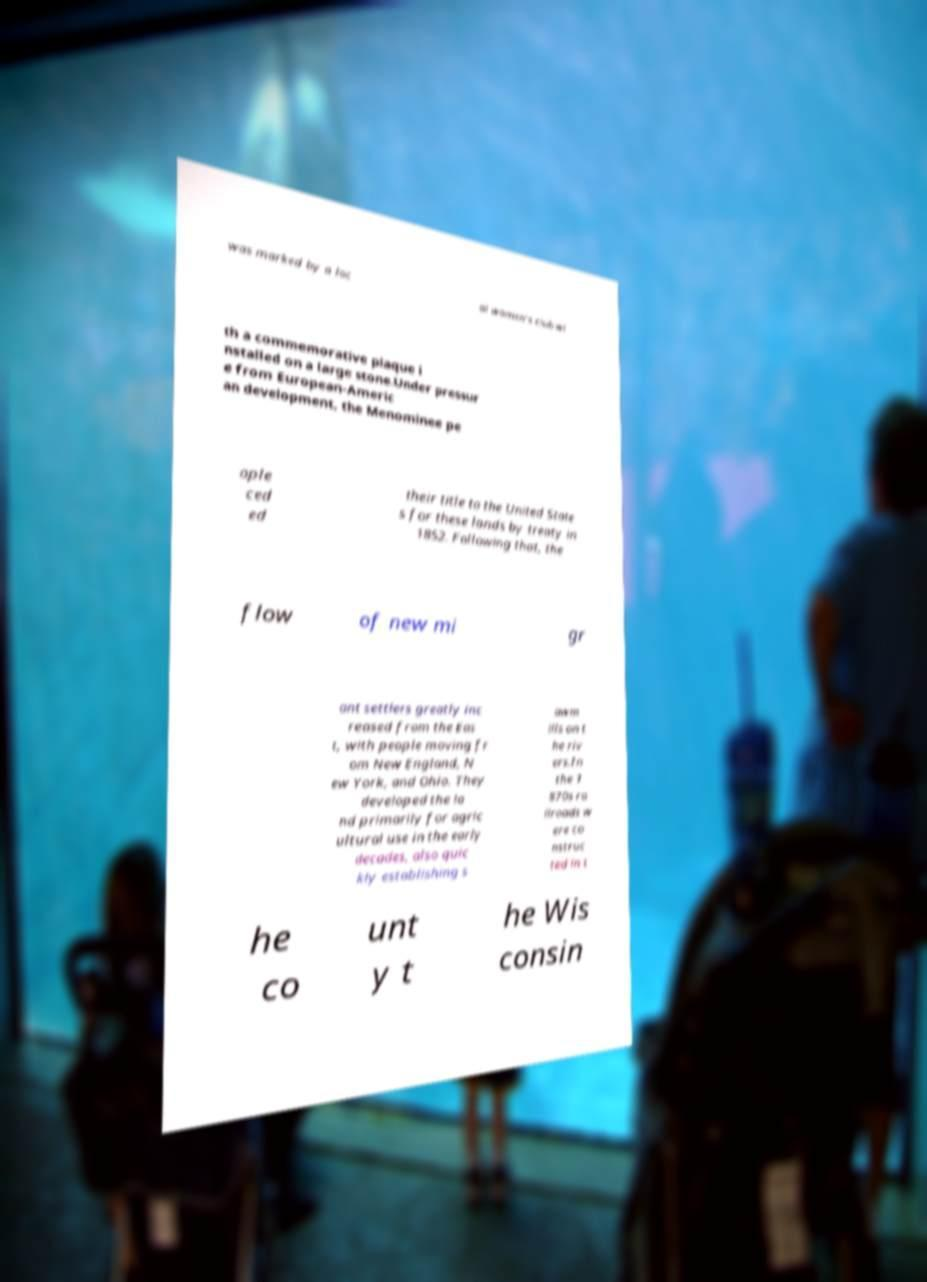Please identify and transcribe the text found in this image. was marked by a loc al women's club wi th a commemorative plaque i nstalled on a large stone.Under pressur e from European-Americ an development, the Menominee pe ople ced ed their title to the United State s for these lands by treaty in 1852. Following that, the flow of new mi gr ant settlers greatly inc reased from the Eas t, with people moving fr om New England, N ew York, and Ohio. They developed the la nd primarily for agric ultural use in the early decades, also quic kly establishing s awm ills on t he riv ers.In the 1 870s ra ilroads w ere co nstruc ted in t he co unt y t he Wis consin 